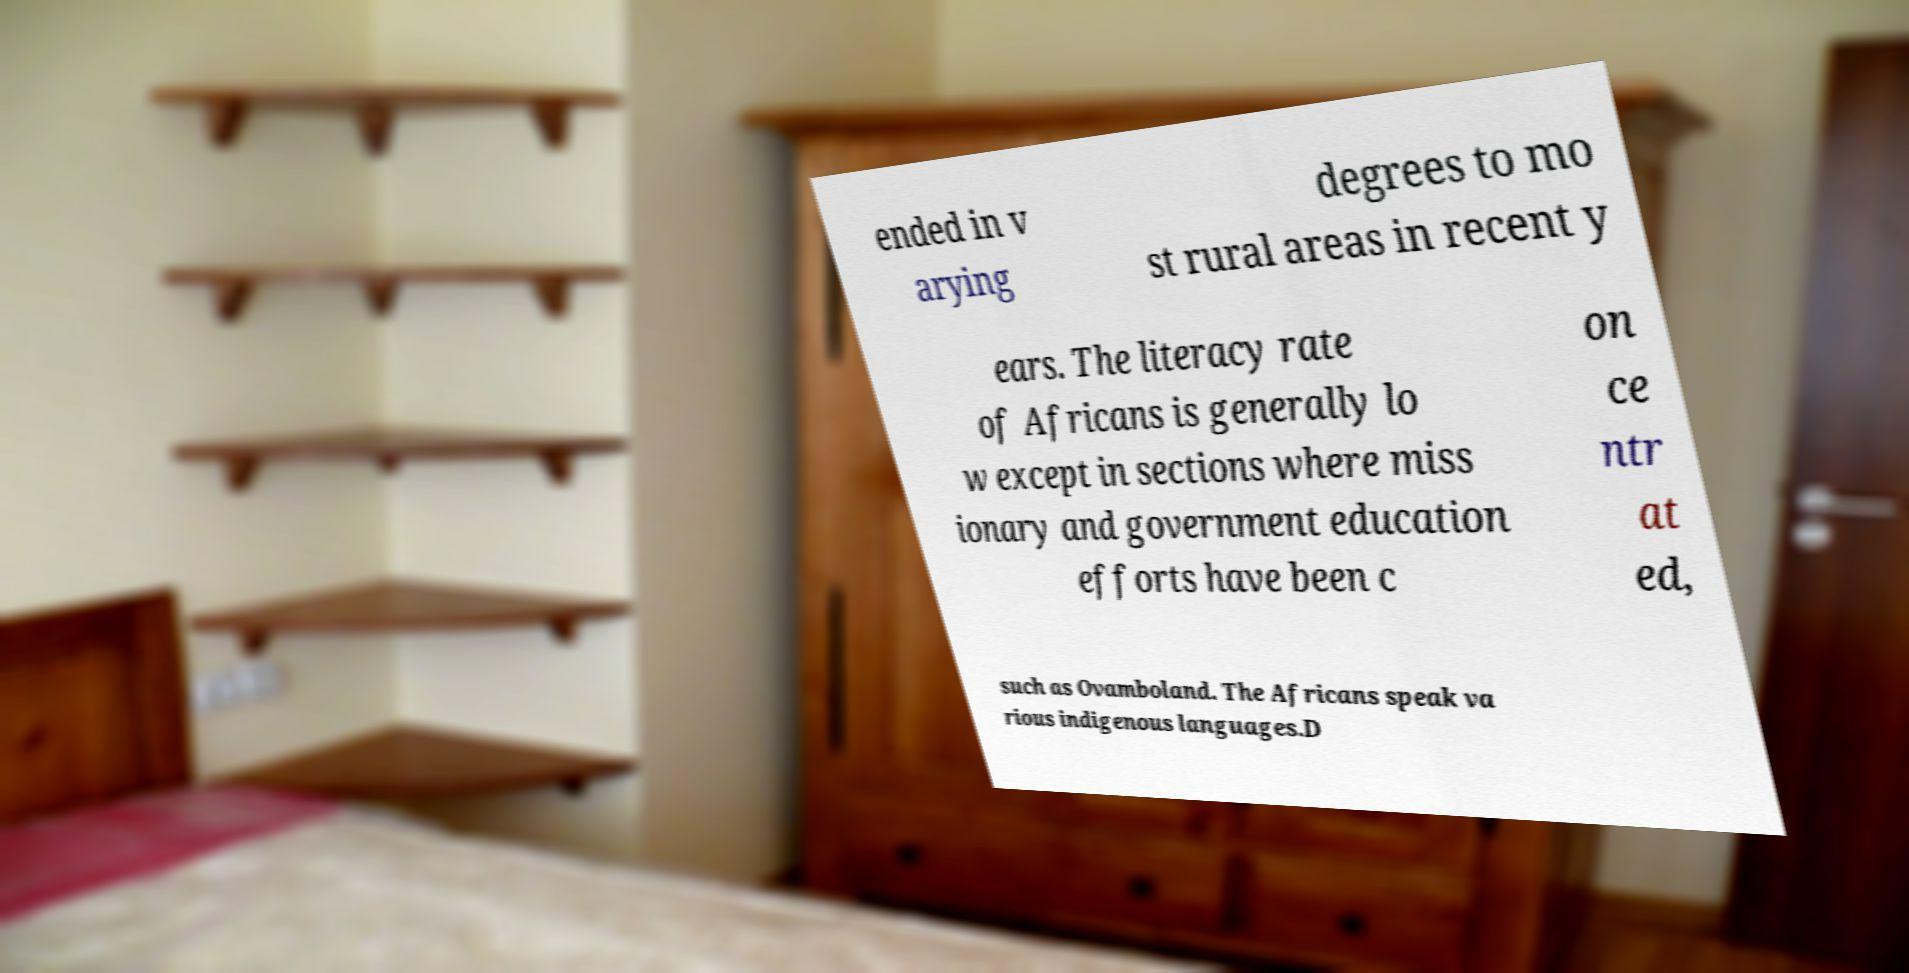There's text embedded in this image that I need extracted. Can you transcribe it verbatim? ended in v arying degrees to mo st rural areas in recent y ears. The literacy rate of Africans is generally lo w except in sections where miss ionary and government education efforts have been c on ce ntr at ed, such as Ovamboland. The Africans speak va rious indigenous languages.D 